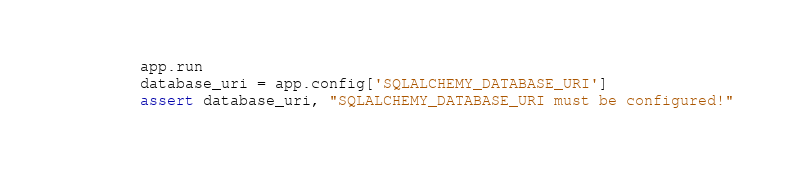<code> <loc_0><loc_0><loc_500><loc_500><_Python_>        app.run
        database_uri = app.config['SQLALCHEMY_DATABASE_URI']
        assert database_uri, "SQLALCHEMY_DATABASE_URI must be configured!"
</code> 